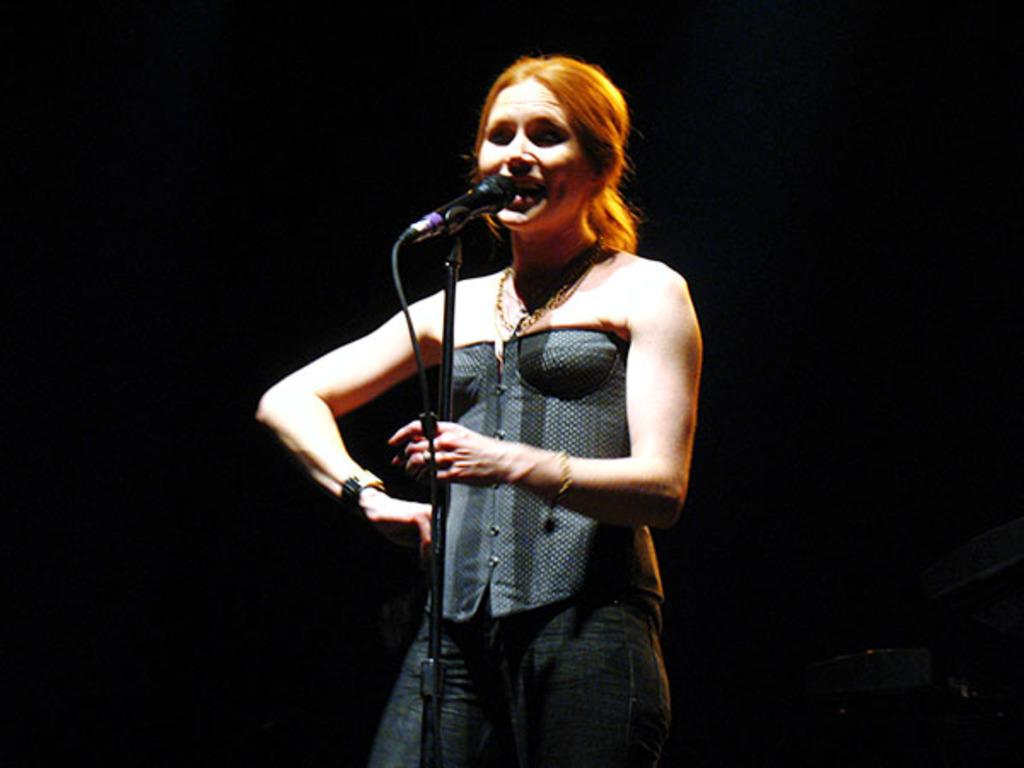Who is the main subject in the image? There is a girl in the image. Where is the girl located in the image? The girl is standing on a stage. What is the girl doing in the image? The girl is singing. What can be seen near the girl in the image? There is a microphone stand in the image. What is the color of the background in the image? The background of the image is black. How many soaps are on the stage with the girl in the image? There are no soaps present in the image. What type of toy can be seen in the girl's hand while she is singing? There is no toy visible in the girl's hand or anywhere else in the image. 